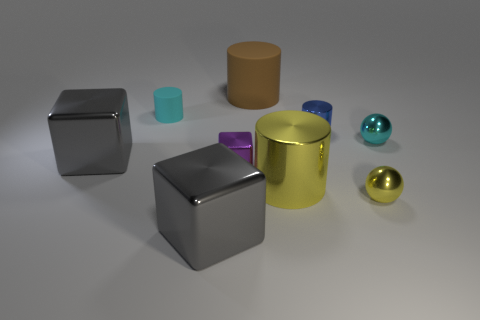Subtract 1 cylinders. How many cylinders are left? 3 Subtract all red cylinders. Subtract all gray spheres. How many cylinders are left? 4 Add 1 large yellow cylinders. How many objects exist? 10 Subtract all spheres. How many objects are left? 7 Subtract all tiny cyan cylinders. Subtract all gray objects. How many objects are left? 6 Add 7 yellow metallic cylinders. How many yellow metallic cylinders are left? 8 Add 2 cyan objects. How many cyan objects exist? 4 Subtract 0 green spheres. How many objects are left? 9 